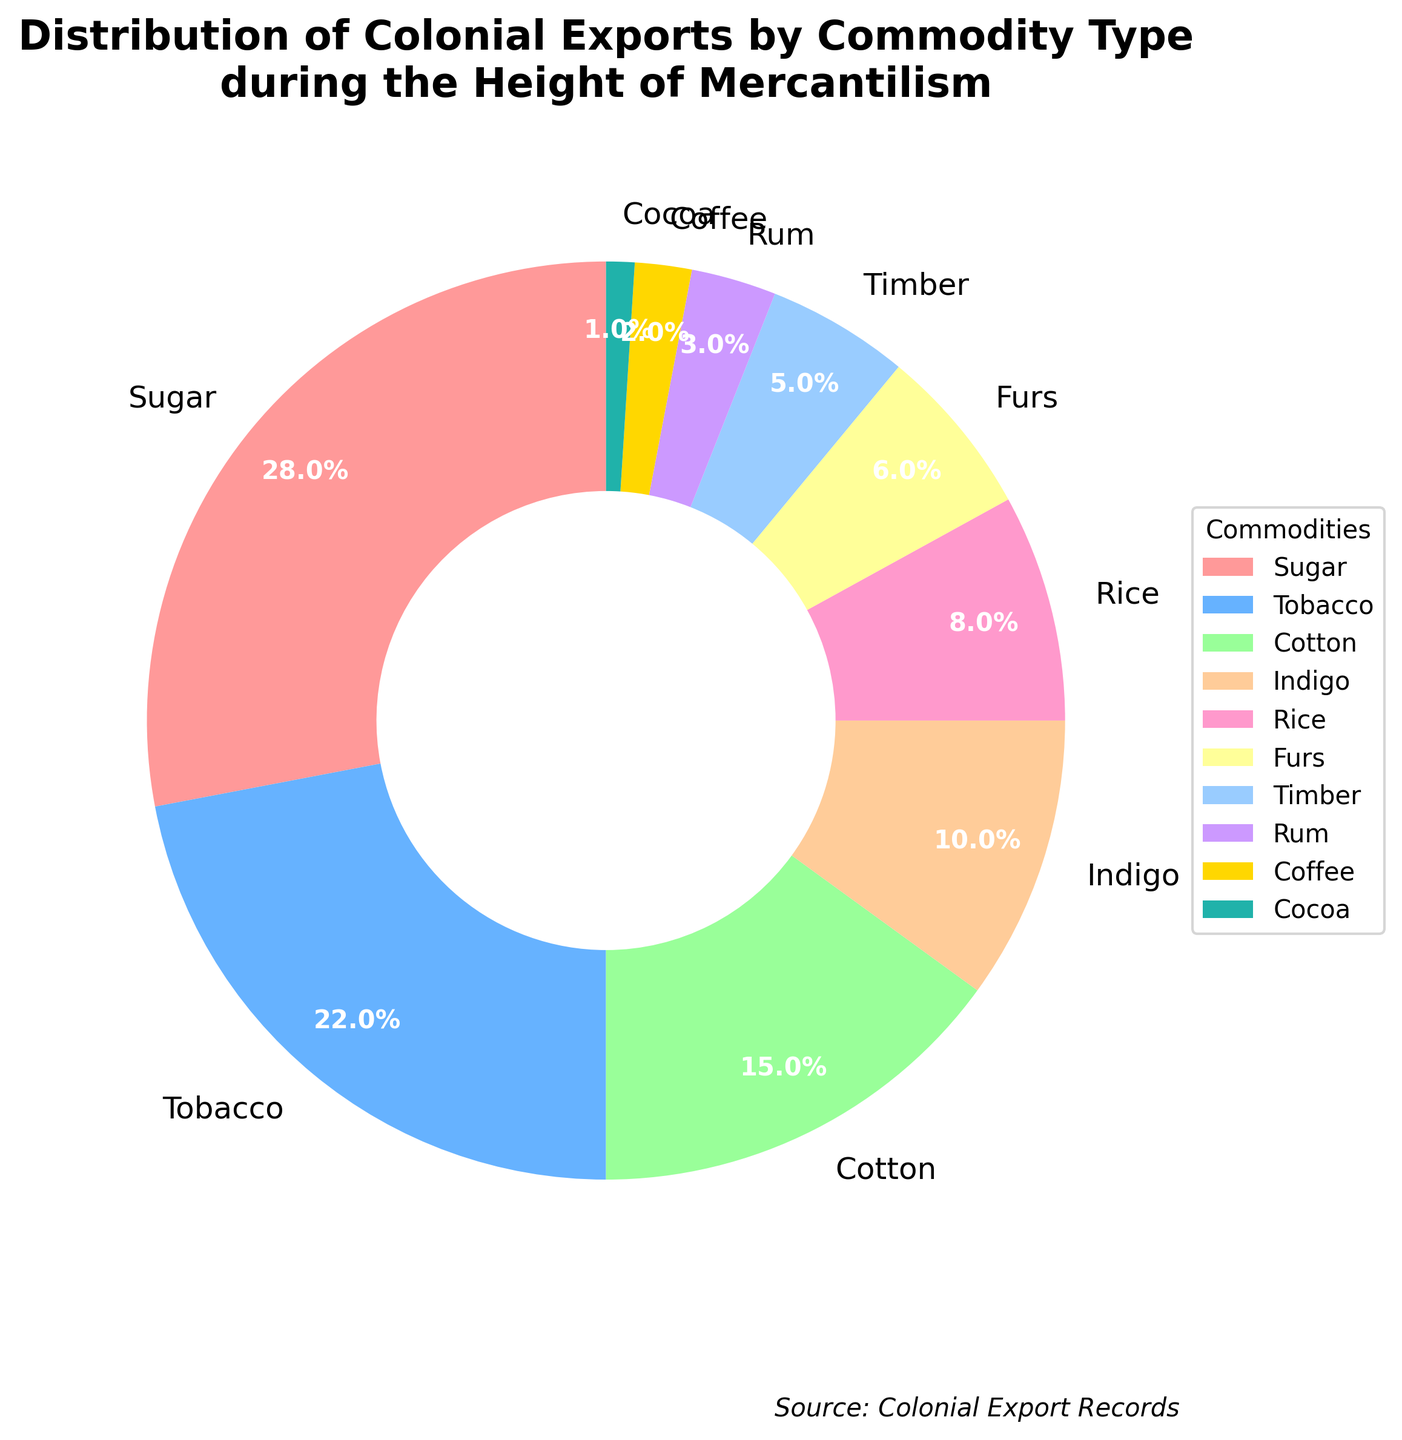Which commodity had the highest percentage of colonial exports? The commodity with the highest percentage of colonial exports can be identified by looking for the largest section in the pie chart. The largest section represents Sugar.
Answer: Sugar Which commodity had the least representation in colonial exports? The commodity with the least representation will be the smallest section of the pie chart. The smallest section is labeled Cocoa.
Answer: Cocoa How does the combined percentage of Sugar and Tobacco exports compare to the combined percentage of Cotton and Rice? First, find the percentages for each commodity: Sugar (28%), Tobacco (22%), Cotton (15%), and Rice (8%). Sum the percentages for each pair: Sugar + Tobacco = 28% + 22% = 50%; Cotton + Rice = 15% + 8% = 23%. Compare these two sums: 50% is greater than 23%.
Answer: 50% is greater than 23% What percentage of colonial exports is represented by Rum and Coffee combined? The percentages for Rum and Coffee are 3% and 2% respectively. Add these percentages together: 3% + 2% = 5%.
Answer: 5% If you add the percentages of Indigo and Rice, how does this total compare to the percentage of Tobacco exports? Indigo and Rice have percentages of 10% and 8%. Add these together: 10% + 8% = 18%. The percentage for Tobacco is 22%. Compare these two sums: 18% is less than 22%.
Answer: 18% is less than 22% What is the visual distinction used to identify different commodity types in the pie chart? Different commodity types are identified using distinct colors in the pie chart. Each section has a unique color to represent a specific commodity.
Answer: Distinct colors Is the percentage of Furs greater than or less than the percentage of Timber? The percentage of Furs is 6% and the percentage of Timber is 5%. Compare these percentages: 6% is greater than 5%.
Answer: 6% is greater than 5% Which two commodities together make up the same percentage as Cotton exports? Cotton exports represent 15%. Find two commodities whose percentages sum to 15%. Rum (3%) and Indigo (10%) together make up 13%, not matching. Timber (5%) and Coffee (2%) together make 7%, also not matching. The combinations continue until you find none directly match 15%.
Answer: None What is the sum of the percentages of the four least-exported commodities? Identify the four least-exported commodities: Cocoa (1%), Coffee (2%), Rum (3%), and Timber (5%). Sum these percentages: 1% + 2% + 3% + 5% = 11%.
Answer: 11% How does the percentage of Rice exports compare to the combined percentage of Cocoa and Coffee? The percentage of Rice exports is 8%. Cocoa and Coffee together make up 1% + 2% = 3%. Compare the percentages: 8% is greater than 3%.
Answer: 8% is greater than 3% 